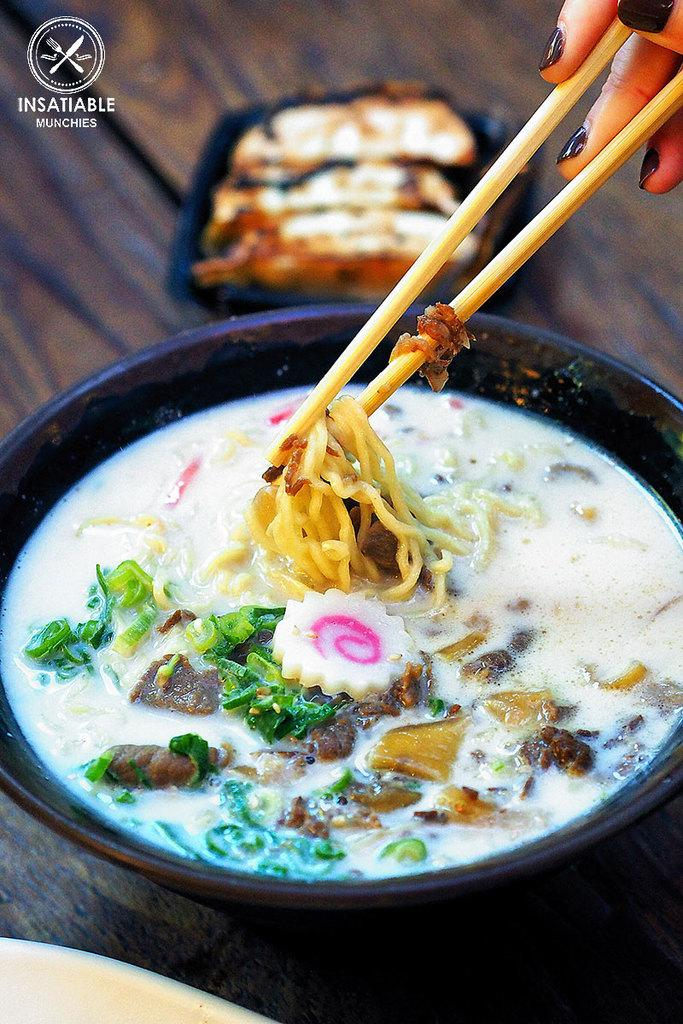What is present on the table in the image? There is a bowl, food, and a plate on the table in the image. What type of food can be seen in the image? The food in the image is not specified, but it is present. What is the bowl used for in the image? The bowl is likely used for holding or serving the food. What are the sticks being held for in the image? The sticks being held in hands are not specified, but they are likely used for eating or handling the food. What type of milk is being served by the father in the image? There is no father or milk present in the image. How many soldiers are visible in the army in the image? There is no army or soldiers present in the image. 